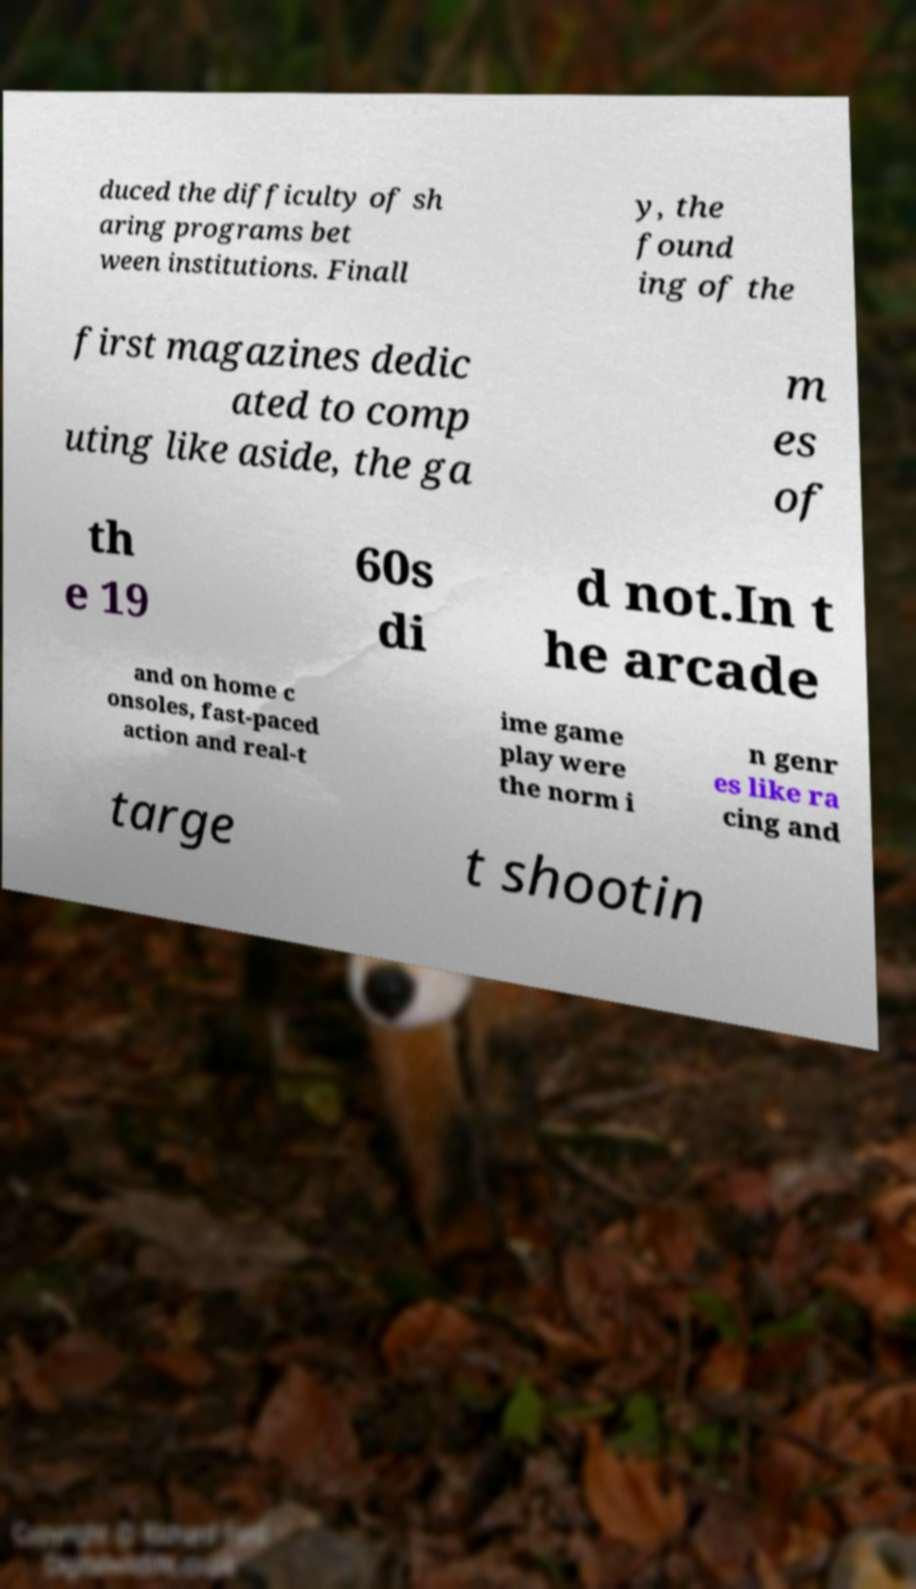Could you assist in decoding the text presented in this image and type it out clearly? duced the difficulty of sh aring programs bet ween institutions. Finall y, the found ing of the first magazines dedic ated to comp uting like aside, the ga m es of th e 19 60s di d not.In t he arcade and on home c onsoles, fast-paced action and real-t ime game play were the norm i n genr es like ra cing and targe t shootin 